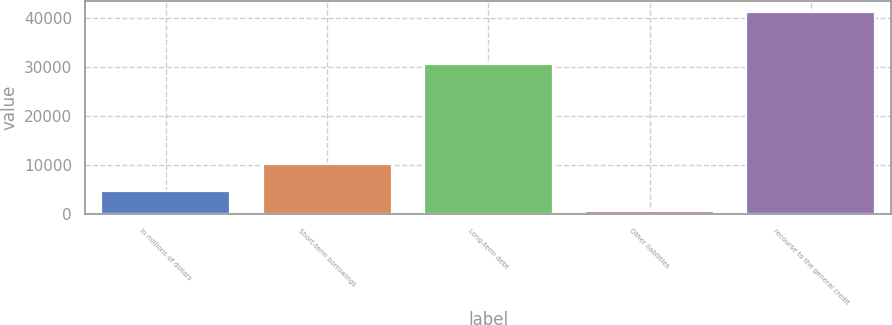Convert chart. <chart><loc_0><loc_0><loc_500><loc_500><bar_chart><fcel>In millions of dollars<fcel>Short-term borrowings<fcel>Long-term debt<fcel>Other liabilities<fcel>recourse to the general credit<nl><fcel>4674.4<fcel>10142<fcel>30492<fcel>611<fcel>41245<nl></chart> 